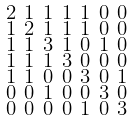Convert formula to latex. <formula><loc_0><loc_0><loc_500><loc_500>\begin{smallmatrix} 2 & 1 & 1 & 1 & 1 & 0 & 0 \\ 1 & 2 & 1 & 1 & 1 & 0 & 0 \\ 1 & 1 & 3 & 1 & 0 & 1 & 0 \\ 1 & 1 & 1 & 3 & 0 & 0 & 0 \\ 1 & 1 & 0 & 0 & 3 & 0 & 1 \\ 0 & 0 & 1 & 0 & 0 & 3 & 0 \\ 0 & 0 & 0 & 0 & 1 & 0 & 3 \end{smallmatrix}</formula> 